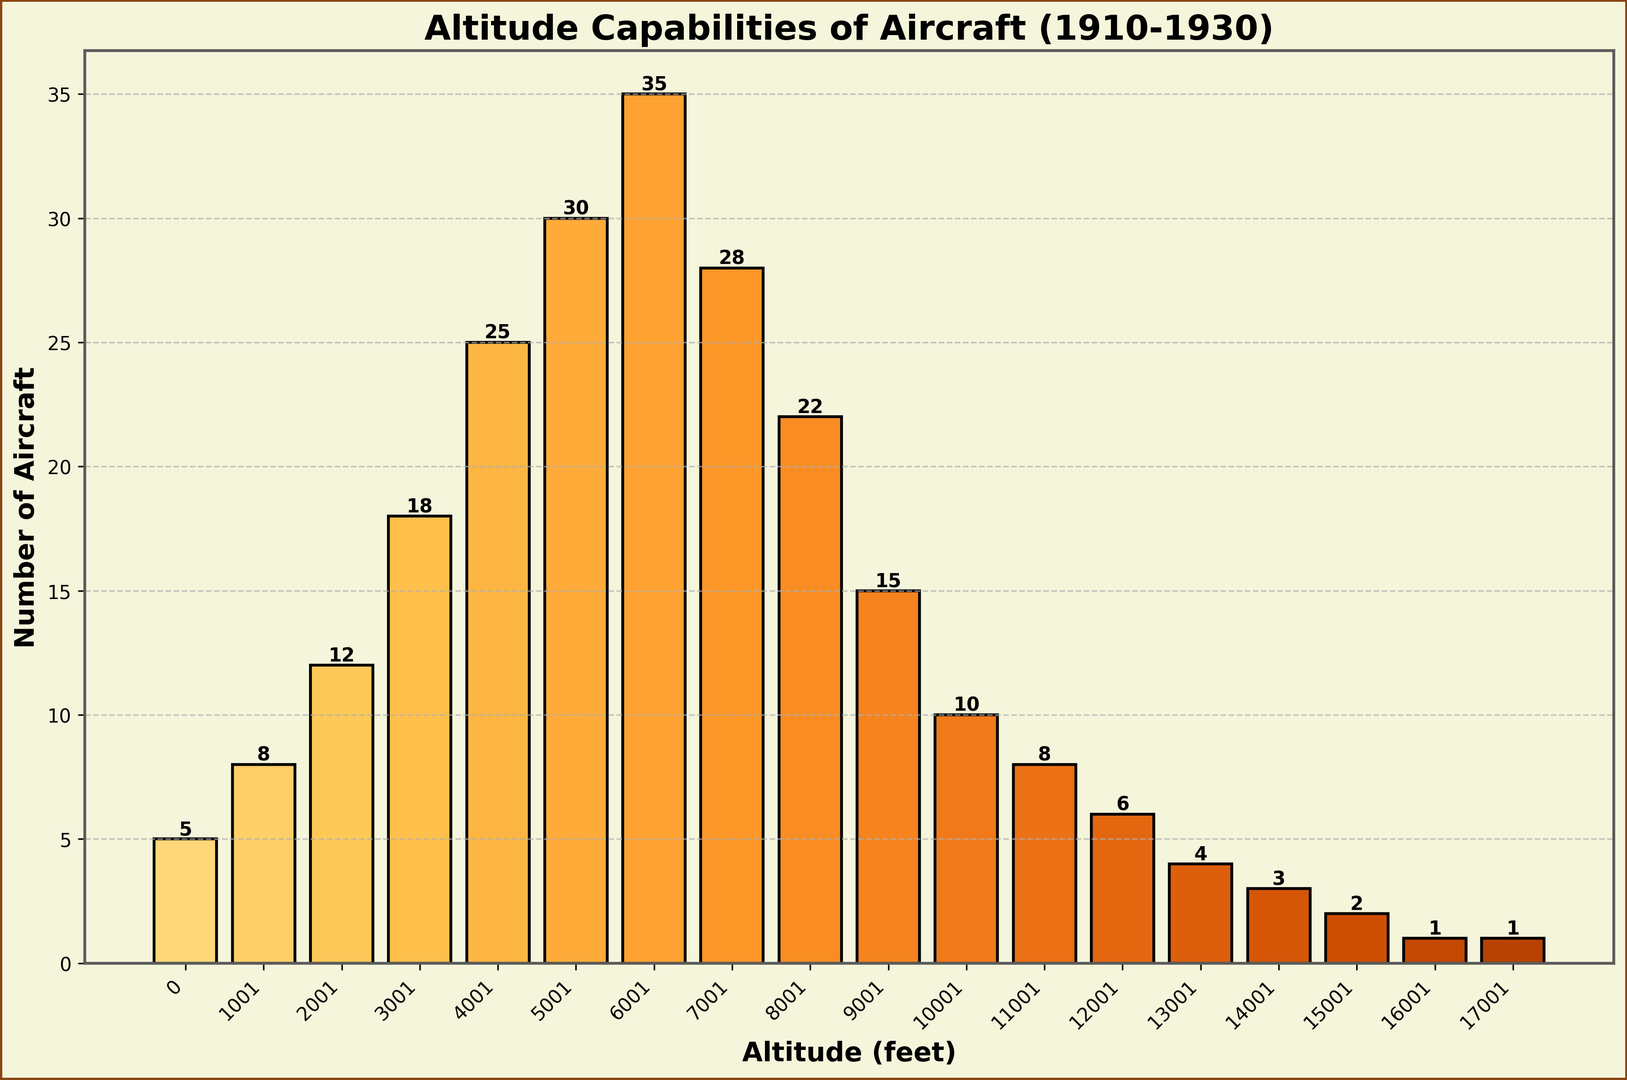What's the most common altitude capability range for aircraft produced between 1910 and 1930? The bar with the highest height indicates the most common altitude range. In this case, the bar representing the 6001-7000 feet range has the highest value with 35 aircraft.
Answer: 6001-7000 feet How many more aircraft could reach 5001-6000 feet compared to 0-1000 feet? The bar for 5001-6000 feet shows 30 aircraft, and the bar for 0-1000 feet shows 5. Subtracting these values gives the difference.
Answer: 25 What is the total number of aircraft that could reach altitudes of 10001 feet and higher? By adding the counts from the bars for 10001-11000 feet (10), 11001-12000 feet (8), 12001-13000 feet (6), 13001-14000 feet (4), 14001-15000 feet (3), 15001-16000 feet (2), 16001-17000 feet (1), and 17001-18000 feet (1), we get the total. 10 + 8 + 6 + 4 + 3 + 2 + 1 + 1 = 35
Answer: 35 Which altitude range has the least number of aircraft? The bars representing 16001-17000 feet and 17001-18000 feet both have a height of 1, indicating the least number of aircraft.
Answer: 16001-17000 feet and 17001-18000 feet How does the number of aircraft capable of reaching 7001-8000 feet compare to those reaching 5001-6000 feet? The bar for 7001-8000 feet has a height of 28, while the bar for 5001-6000 feet has a height of 30. This means the former is 2 aircraft less than the latter.
Answer: 2 fewer What is the average number of aircraft across all altitude ranges shown? First, sum all the counts from each range: 5 + 8 + 12 + 18 + 25 + 30 + 35 + 28 + 22 + 15 + 10 + 8 + 6 + 4 + 3 + 2 + 1 + 1 = 233. There are 18 altitude ranges, so divide the total by 18. 233 / 18 ≈ 12.94
Answer: ≈ 12.94 What altitude range has the second-highest number of aircraft? The highest number of aircraft is 35 for the 6001-7000 feet range. The second-highest is 30 for the 5001-6000 feet range.
Answer: 5001-6000 feet By how much does the number of aircraft in the 4001-5000 feet range exceed those in the 12001-13000 feet range? The 4001-5000 feet range has 25 aircraft, and the 12001-13000 feet range has 6. The difference is 25 - 6.
Answer: 19 